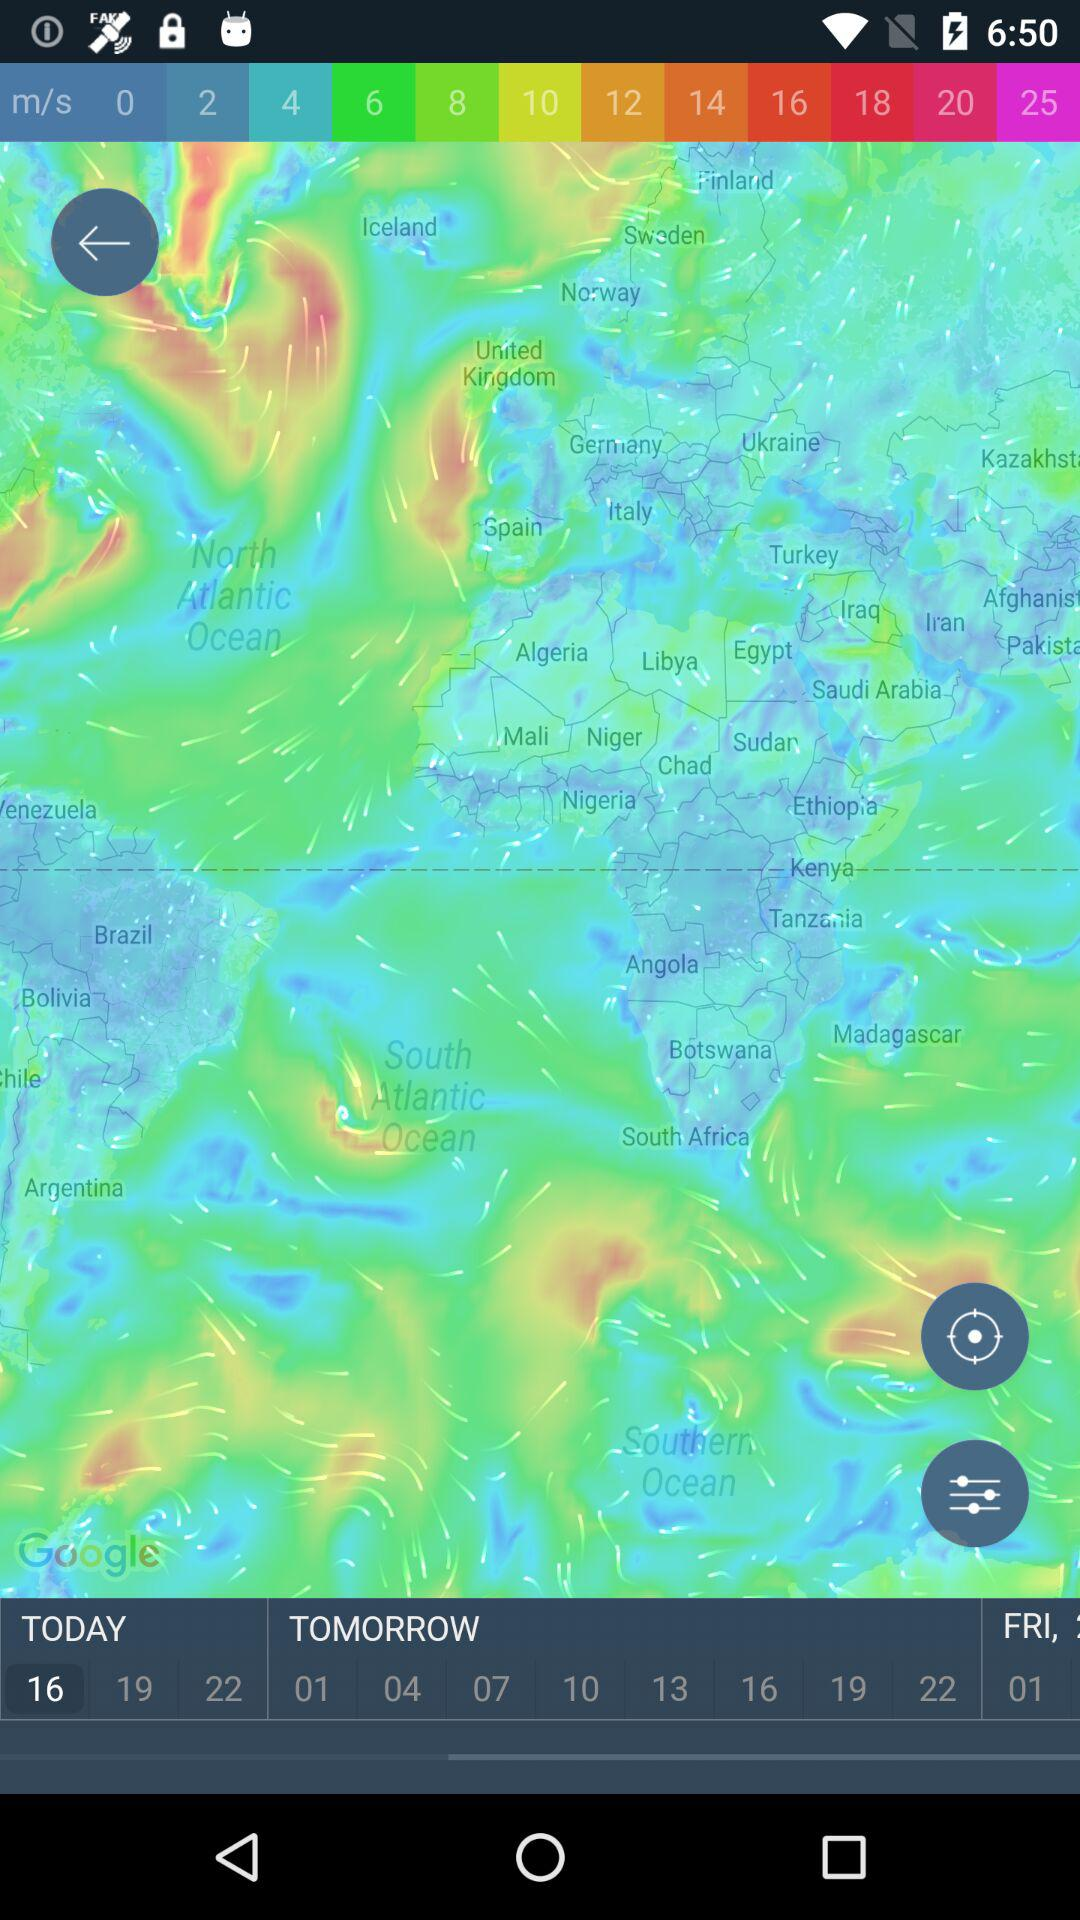Which date is selected in the "TODAY" option? The selected date is 16. 